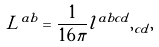Convert formula to latex. <formula><loc_0><loc_0><loc_500><loc_500>L ^ { a b } = \frac { 1 } { 1 6 \pi } l ^ { a b c d } , _ { c d } ,</formula> 